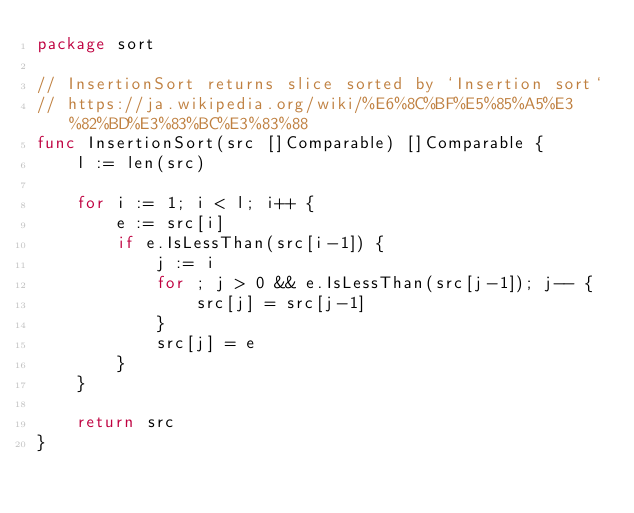<code> <loc_0><loc_0><loc_500><loc_500><_Go_>package sort

// InsertionSort returns slice sorted by `Insertion sort`
// https://ja.wikipedia.org/wiki/%E6%8C%BF%E5%85%A5%E3%82%BD%E3%83%BC%E3%83%88
func InsertionSort(src []Comparable) []Comparable {
	l := len(src)

	for i := 1; i < l; i++ {
		e := src[i]
		if e.IsLessThan(src[i-1]) {
			j := i
			for ; j > 0 && e.IsLessThan(src[j-1]); j-- {
				src[j] = src[j-1]
			}
			src[j] = e
		}
	}

	return src
}
</code> 